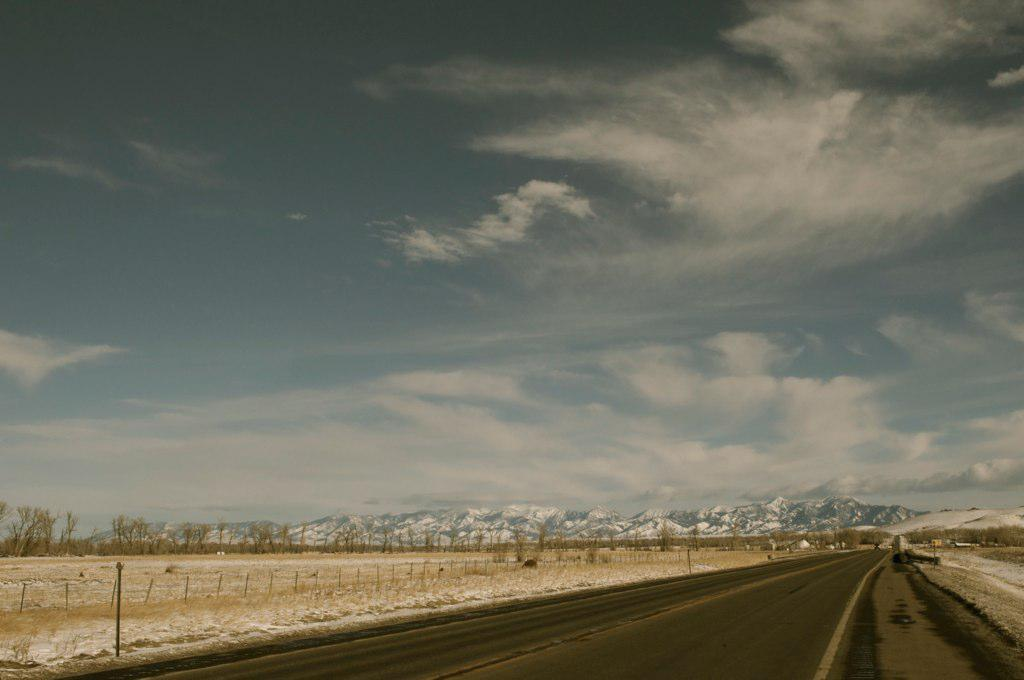What is the main feature of the image? There is a road in the image. What type of fencing can be seen along the road? Cement fencing poles are present in the image. What kind of vegetation is visible in the image? Dried trees are visible in the image. What is the terrain like in the background of the image? There are hills with snow in the image. What is visible at the top of the image? The sky is visible at the top of the image. What can be seen in the sky? Clouds are present in the sky. Where is the patch of water located in the image? There is no patch of water present in the image. What type of paper can be seen blowing in the wind in the image? There is no paper visible in the image. 